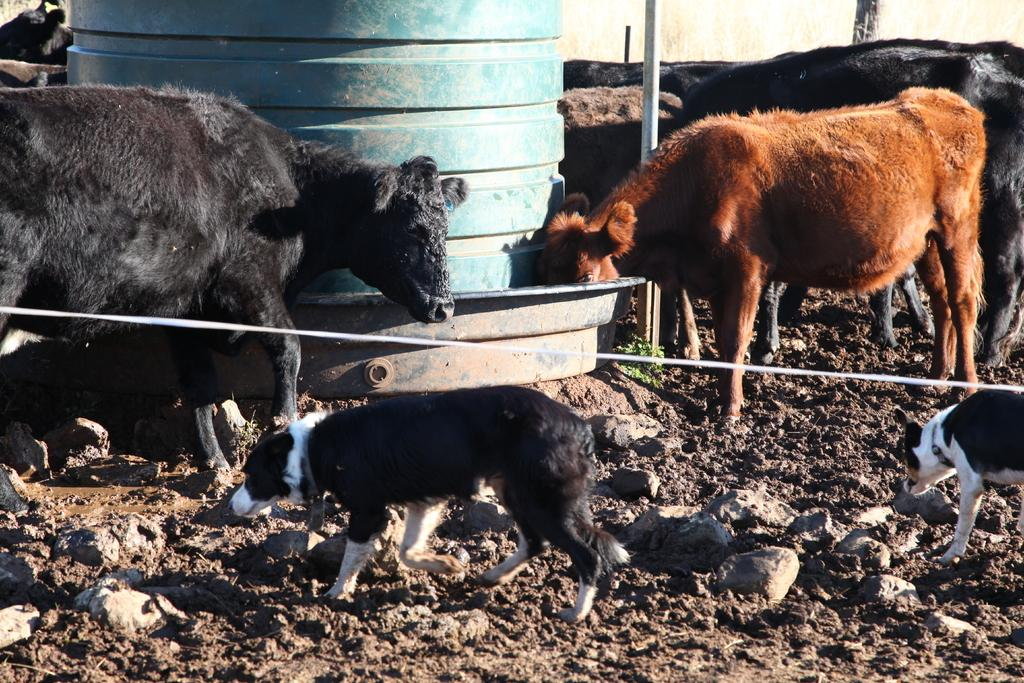What type of animals can be seen in the image? There are cows and dogs in the image. What is the large object in the image? There is a tank in the image. What is present at the bottom of the image? There are rocks at the bottom of the image. What can be seen at the center of the image? There appears to be a rope at the center of the image. What type of playground equipment can be seen in the image? There is no playground equipment present in the image. What achievement is the dog celebrating in the image? There is no indication of an achievement in the image; the dogs are simply present with the cows and other objects. 